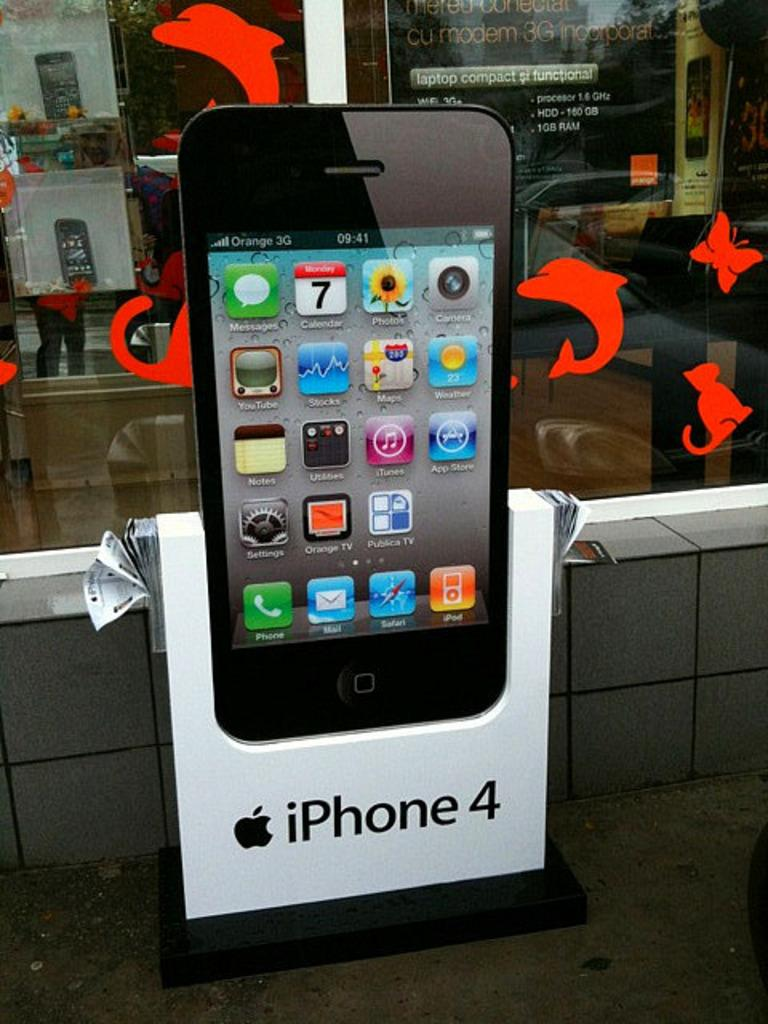<image>
Present a compact description of the photo's key features. An iPhone 4 large model outside of a laptop computer store with flyers at the side. 